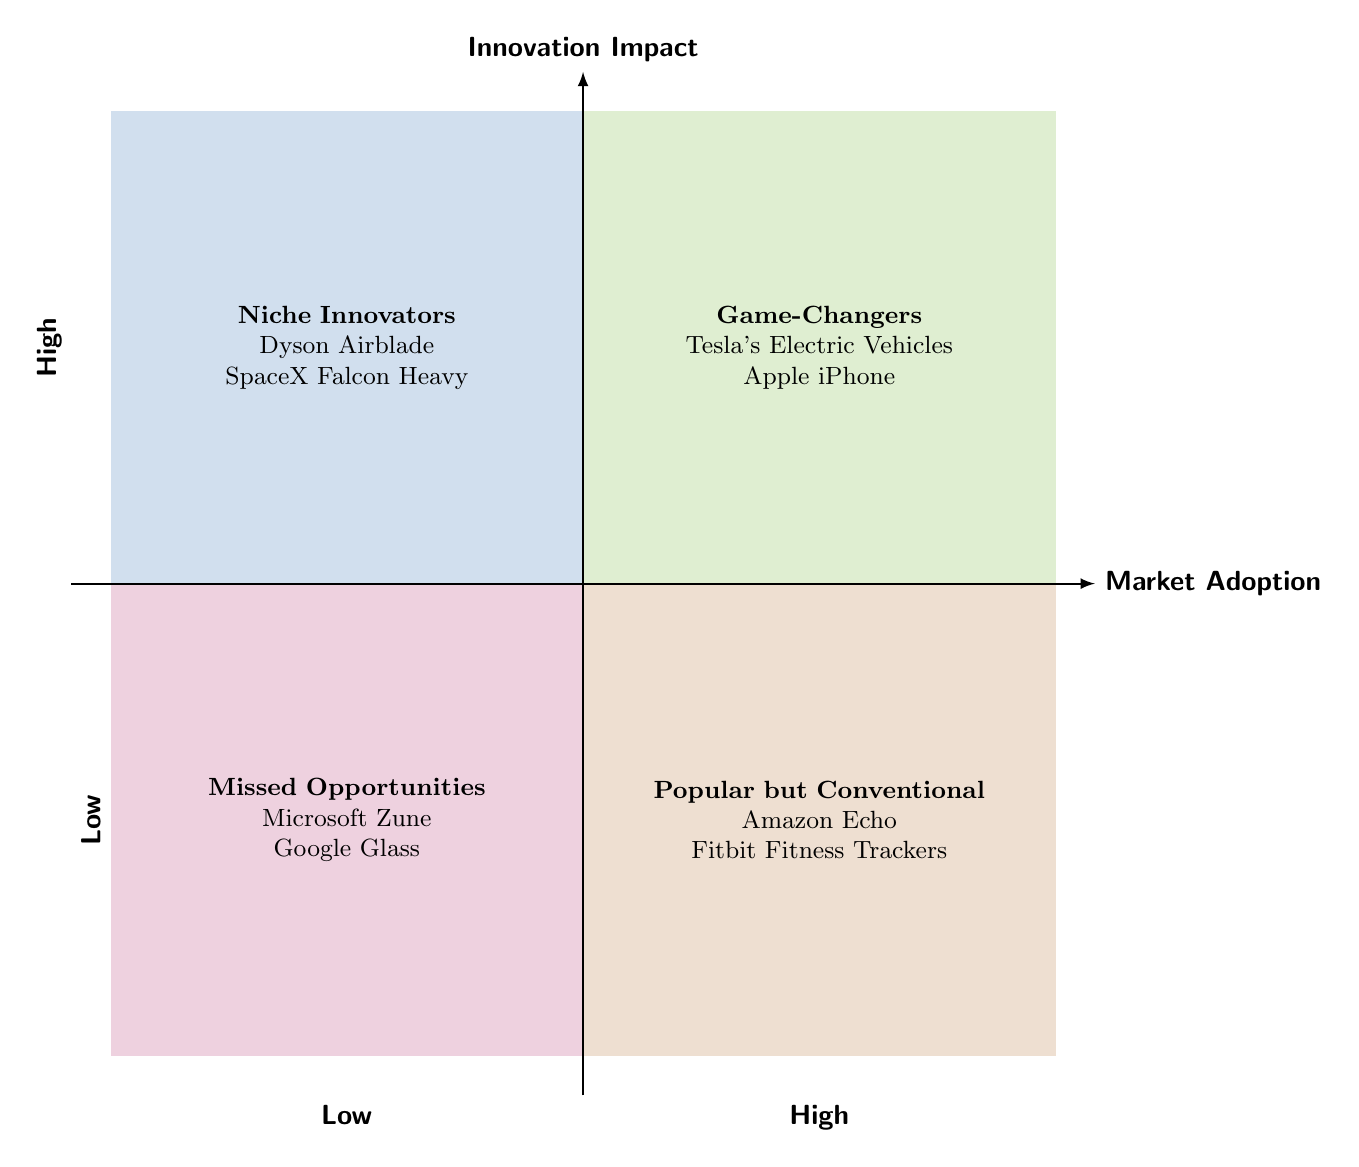What is the label of the top right quadrant? The top right quadrant of the diagram is labeled "Game-Changers", indicating a combination of high innovation impact and high market adoption.
Answer: Game-Changers How many elements are in the "Niche Innovators" quadrant? The "Niche Innovators" quadrant contains two elements: Dyson Airblade and SpaceX Falcon Heavy, which are both highly innovative but not widely adopted.
Answer: 2 Which product is in the "Popular but Conventional" quadrant? The "Popular but Conventional" quadrant features products like Amazon Echo and Fitbit Fitness Trackers, which achieve high market adoption through incremental improvements rather than groundbreaking innovation.
Answer: Amazon Echo What characterizes the "Missed Opportunities" quadrant? The "Missed Opportunities" quadrant includes products that have low innovation impact and low market adoption, such as Microsoft Zune and Google Glass, indicating they did not capture market success.
Answer: Low innovation and low adoption Which quadrant has the highest market adoption? The quadrant with the highest market adoption is the "Game-Changers" quadrant, showcasing products that are both innovative and widely adopted in the market.
Answer: Game-Changers Name one example of a "Niche Innovator". One example of a "Niche Innovator" is the Dyson Airblade, which is known for its innovation but is limited to specific market segments.
Answer: Dyson Airblade What is the primary distinction between "Game-Changers" and "Popular but Conventional"? "Game-Changers" are characterized by high innovation and high market adoption, while "Popular but Conventional" are low in innovation despite having high market adoption.
Answer: High innovation vs. low innovation How many quadrants are there in the diagram? The diagram features four quadrants: Game-Changers, Niche Innovators, Popular but Conventional, and Missed Opportunities.
Answer: 4 What defines the "Popularity" of products in the "Popular but Conventional" quadrant? Products in the "Popular but Conventional" quadrant are popular due to their wide market adoption, but they do not feature significant innovation or breakthroughs, relying instead on incremental improvements.
Answer: Incremental improvements 